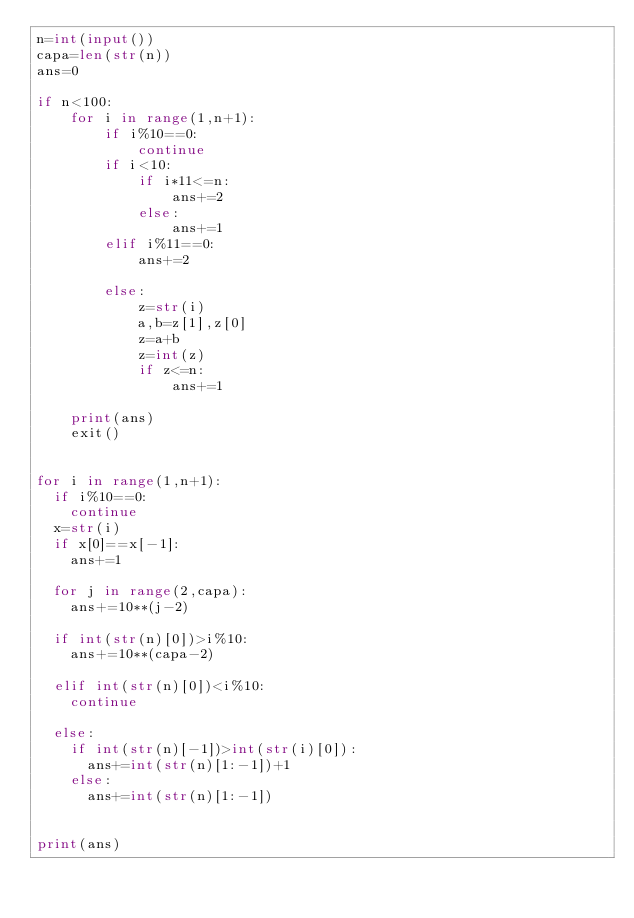Convert code to text. <code><loc_0><loc_0><loc_500><loc_500><_Python_>n=int(input())
capa=len(str(n))
ans=0

if n<100:
    for i in range(1,n+1):
        if i%10==0:
            continue
        if i<10:
            if i*11<=n:
                ans+=2
            else:
                ans+=1
        elif i%11==0:
            ans+=2
    
        else:
            z=str(i)
            a,b=z[1],z[0]
            z=a+b
            z=int(z)
            if z<=n:
                ans+=1
    
    print(ans)
    exit()


for i in range(1,n+1):
  if i%10==0:
    continue
  x=str(i)
  if x[0]==x[-1]:
    ans+=1
  
  for j in range(2,capa):
    ans+=10**(j-2)
    
  if int(str(n)[0])>i%10:
    ans+=10**(capa-2)
    
  elif int(str(n)[0])<i%10:
    continue
    
  else:
    if int(str(n)[-1])>int(str(i)[0]):
      ans+=int(str(n)[1:-1])+1
    else:
      ans+=int(str(n)[1:-1])
      
      
print(ans)</code> 